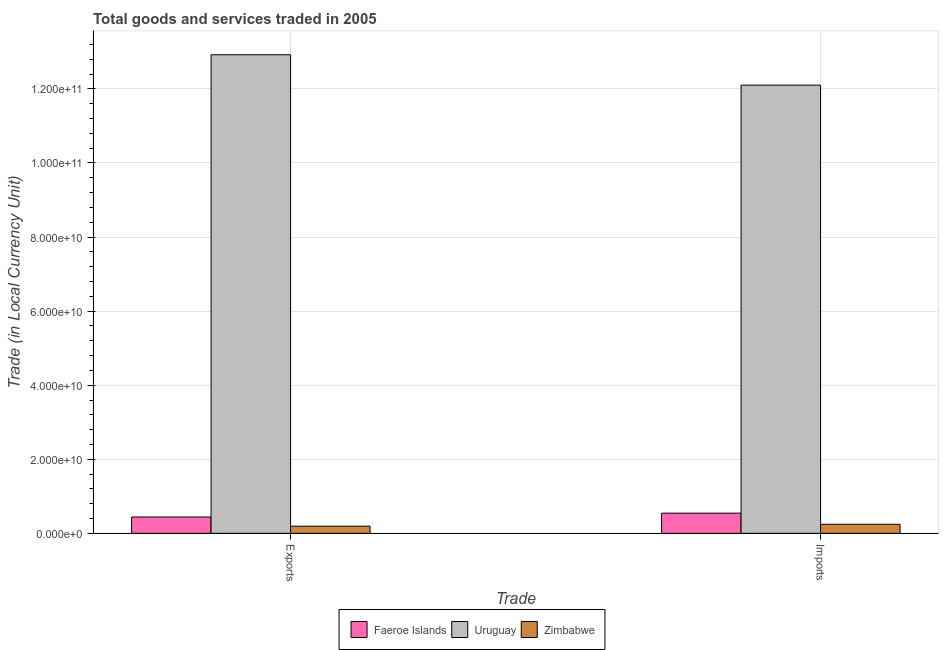How many different coloured bars are there?
Offer a terse response. 3. How many bars are there on the 1st tick from the left?
Keep it short and to the point. 3. What is the label of the 2nd group of bars from the left?
Keep it short and to the point. Imports. What is the imports of goods and services in Uruguay?
Your response must be concise. 1.21e+11. Across all countries, what is the maximum imports of goods and services?
Give a very brief answer. 1.21e+11. Across all countries, what is the minimum imports of goods and services?
Offer a terse response. 2.45e+09. In which country was the imports of goods and services maximum?
Make the answer very short. Uruguay. In which country was the export of goods and services minimum?
Give a very brief answer. Zimbabwe. What is the total export of goods and services in the graph?
Offer a very short reply. 1.36e+11. What is the difference between the export of goods and services in Uruguay and that in Faeroe Islands?
Ensure brevity in your answer.  1.25e+11. What is the difference between the imports of goods and services in Zimbabwe and the export of goods and services in Faeroe Islands?
Make the answer very short. -1.97e+09. What is the average export of goods and services per country?
Provide a succinct answer. 4.52e+1. What is the difference between the imports of goods and services and export of goods and services in Uruguay?
Your answer should be very brief. -8.20e+09. What is the ratio of the export of goods and services in Faeroe Islands to that in Uruguay?
Your response must be concise. 0.03. Is the export of goods and services in Uruguay less than that in Faeroe Islands?
Offer a terse response. No. In how many countries, is the export of goods and services greater than the average export of goods and services taken over all countries?
Provide a succinct answer. 1. What does the 3rd bar from the left in Exports represents?
Your response must be concise. Zimbabwe. What does the 2nd bar from the right in Imports represents?
Provide a succinct answer. Uruguay. Are the values on the major ticks of Y-axis written in scientific E-notation?
Offer a terse response. Yes. How many legend labels are there?
Make the answer very short. 3. What is the title of the graph?
Offer a terse response. Total goods and services traded in 2005. Does "Vanuatu" appear as one of the legend labels in the graph?
Your response must be concise. No. What is the label or title of the X-axis?
Make the answer very short. Trade. What is the label or title of the Y-axis?
Your answer should be very brief. Trade (in Local Currency Unit). What is the Trade (in Local Currency Unit) of Faeroe Islands in Exports?
Your answer should be very brief. 4.41e+09. What is the Trade (in Local Currency Unit) in Uruguay in Exports?
Your answer should be very brief. 1.29e+11. What is the Trade (in Local Currency Unit) in Zimbabwe in Exports?
Keep it short and to the point. 1.93e+09. What is the Trade (in Local Currency Unit) in Faeroe Islands in Imports?
Keep it short and to the point. 5.45e+09. What is the Trade (in Local Currency Unit) in Uruguay in Imports?
Keep it short and to the point. 1.21e+11. What is the Trade (in Local Currency Unit) in Zimbabwe in Imports?
Provide a succinct answer. 2.45e+09. Across all Trade, what is the maximum Trade (in Local Currency Unit) in Faeroe Islands?
Give a very brief answer. 5.45e+09. Across all Trade, what is the maximum Trade (in Local Currency Unit) in Uruguay?
Keep it short and to the point. 1.29e+11. Across all Trade, what is the maximum Trade (in Local Currency Unit) in Zimbabwe?
Your answer should be compact. 2.45e+09. Across all Trade, what is the minimum Trade (in Local Currency Unit) of Faeroe Islands?
Your answer should be very brief. 4.41e+09. Across all Trade, what is the minimum Trade (in Local Currency Unit) in Uruguay?
Offer a very short reply. 1.21e+11. Across all Trade, what is the minimum Trade (in Local Currency Unit) in Zimbabwe?
Provide a short and direct response. 1.93e+09. What is the total Trade (in Local Currency Unit) of Faeroe Islands in the graph?
Make the answer very short. 9.86e+09. What is the total Trade (in Local Currency Unit) of Uruguay in the graph?
Offer a terse response. 2.50e+11. What is the total Trade (in Local Currency Unit) in Zimbabwe in the graph?
Keep it short and to the point. 4.38e+09. What is the difference between the Trade (in Local Currency Unit) of Faeroe Islands in Exports and that in Imports?
Offer a very short reply. -1.04e+09. What is the difference between the Trade (in Local Currency Unit) in Uruguay in Exports and that in Imports?
Provide a succinct answer. 8.20e+09. What is the difference between the Trade (in Local Currency Unit) in Zimbabwe in Exports and that in Imports?
Your response must be concise. -5.15e+08. What is the difference between the Trade (in Local Currency Unit) of Faeroe Islands in Exports and the Trade (in Local Currency Unit) of Uruguay in Imports?
Ensure brevity in your answer.  -1.17e+11. What is the difference between the Trade (in Local Currency Unit) in Faeroe Islands in Exports and the Trade (in Local Currency Unit) in Zimbabwe in Imports?
Keep it short and to the point. 1.97e+09. What is the difference between the Trade (in Local Currency Unit) in Uruguay in Exports and the Trade (in Local Currency Unit) in Zimbabwe in Imports?
Offer a very short reply. 1.27e+11. What is the average Trade (in Local Currency Unit) in Faeroe Islands per Trade?
Offer a very short reply. 4.93e+09. What is the average Trade (in Local Currency Unit) in Uruguay per Trade?
Make the answer very short. 1.25e+11. What is the average Trade (in Local Currency Unit) in Zimbabwe per Trade?
Your response must be concise. 2.19e+09. What is the difference between the Trade (in Local Currency Unit) of Faeroe Islands and Trade (in Local Currency Unit) of Uruguay in Exports?
Your answer should be compact. -1.25e+11. What is the difference between the Trade (in Local Currency Unit) of Faeroe Islands and Trade (in Local Currency Unit) of Zimbabwe in Exports?
Provide a short and direct response. 2.48e+09. What is the difference between the Trade (in Local Currency Unit) of Uruguay and Trade (in Local Currency Unit) of Zimbabwe in Exports?
Your response must be concise. 1.27e+11. What is the difference between the Trade (in Local Currency Unit) of Faeroe Islands and Trade (in Local Currency Unit) of Uruguay in Imports?
Offer a terse response. -1.16e+11. What is the difference between the Trade (in Local Currency Unit) of Faeroe Islands and Trade (in Local Currency Unit) of Zimbabwe in Imports?
Provide a short and direct response. 3.00e+09. What is the difference between the Trade (in Local Currency Unit) in Uruguay and Trade (in Local Currency Unit) in Zimbabwe in Imports?
Your response must be concise. 1.19e+11. What is the ratio of the Trade (in Local Currency Unit) of Faeroe Islands in Exports to that in Imports?
Provide a succinct answer. 0.81. What is the ratio of the Trade (in Local Currency Unit) in Uruguay in Exports to that in Imports?
Make the answer very short. 1.07. What is the ratio of the Trade (in Local Currency Unit) in Zimbabwe in Exports to that in Imports?
Your answer should be very brief. 0.79. What is the difference between the highest and the second highest Trade (in Local Currency Unit) of Faeroe Islands?
Your answer should be compact. 1.04e+09. What is the difference between the highest and the second highest Trade (in Local Currency Unit) of Uruguay?
Make the answer very short. 8.20e+09. What is the difference between the highest and the second highest Trade (in Local Currency Unit) in Zimbabwe?
Your answer should be compact. 5.15e+08. What is the difference between the highest and the lowest Trade (in Local Currency Unit) of Faeroe Islands?
Your answer should be compact. 1.04e+09. What is the difference between the highest and the lowest Trade (in Local Currency Unit) in Uruguay?
Offer a very short reply. 8.20e+09. What is the difference between the highest and the lowest Trade (in Local Currency Unit) in Zimbabwe?
Your answer should be very brief. 5.15e+08. 